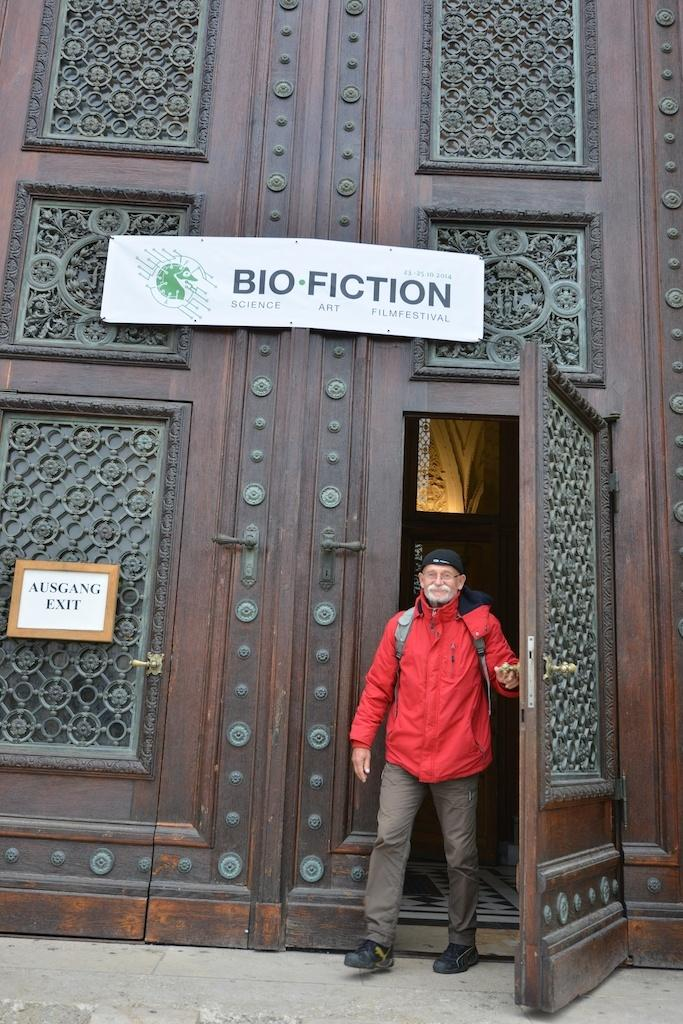What type of door is visible in the image? There is a big wooden door in the image. Are there any additional features attached to the door? Yes, two boards are attached to the door. Who is present in front of the door? A man is standing in front of the door. What is the man wearing? The man is wearing a red color jacket and red color pants. What type of playground equipment can be seen in the image? There is no playground equipment present in the image. How does the man's growth rate compare to the door in the image? The image does not provide any information about the man's growth rate, nor does it allow for a comparison between the man and the door in terms of size or growth. 